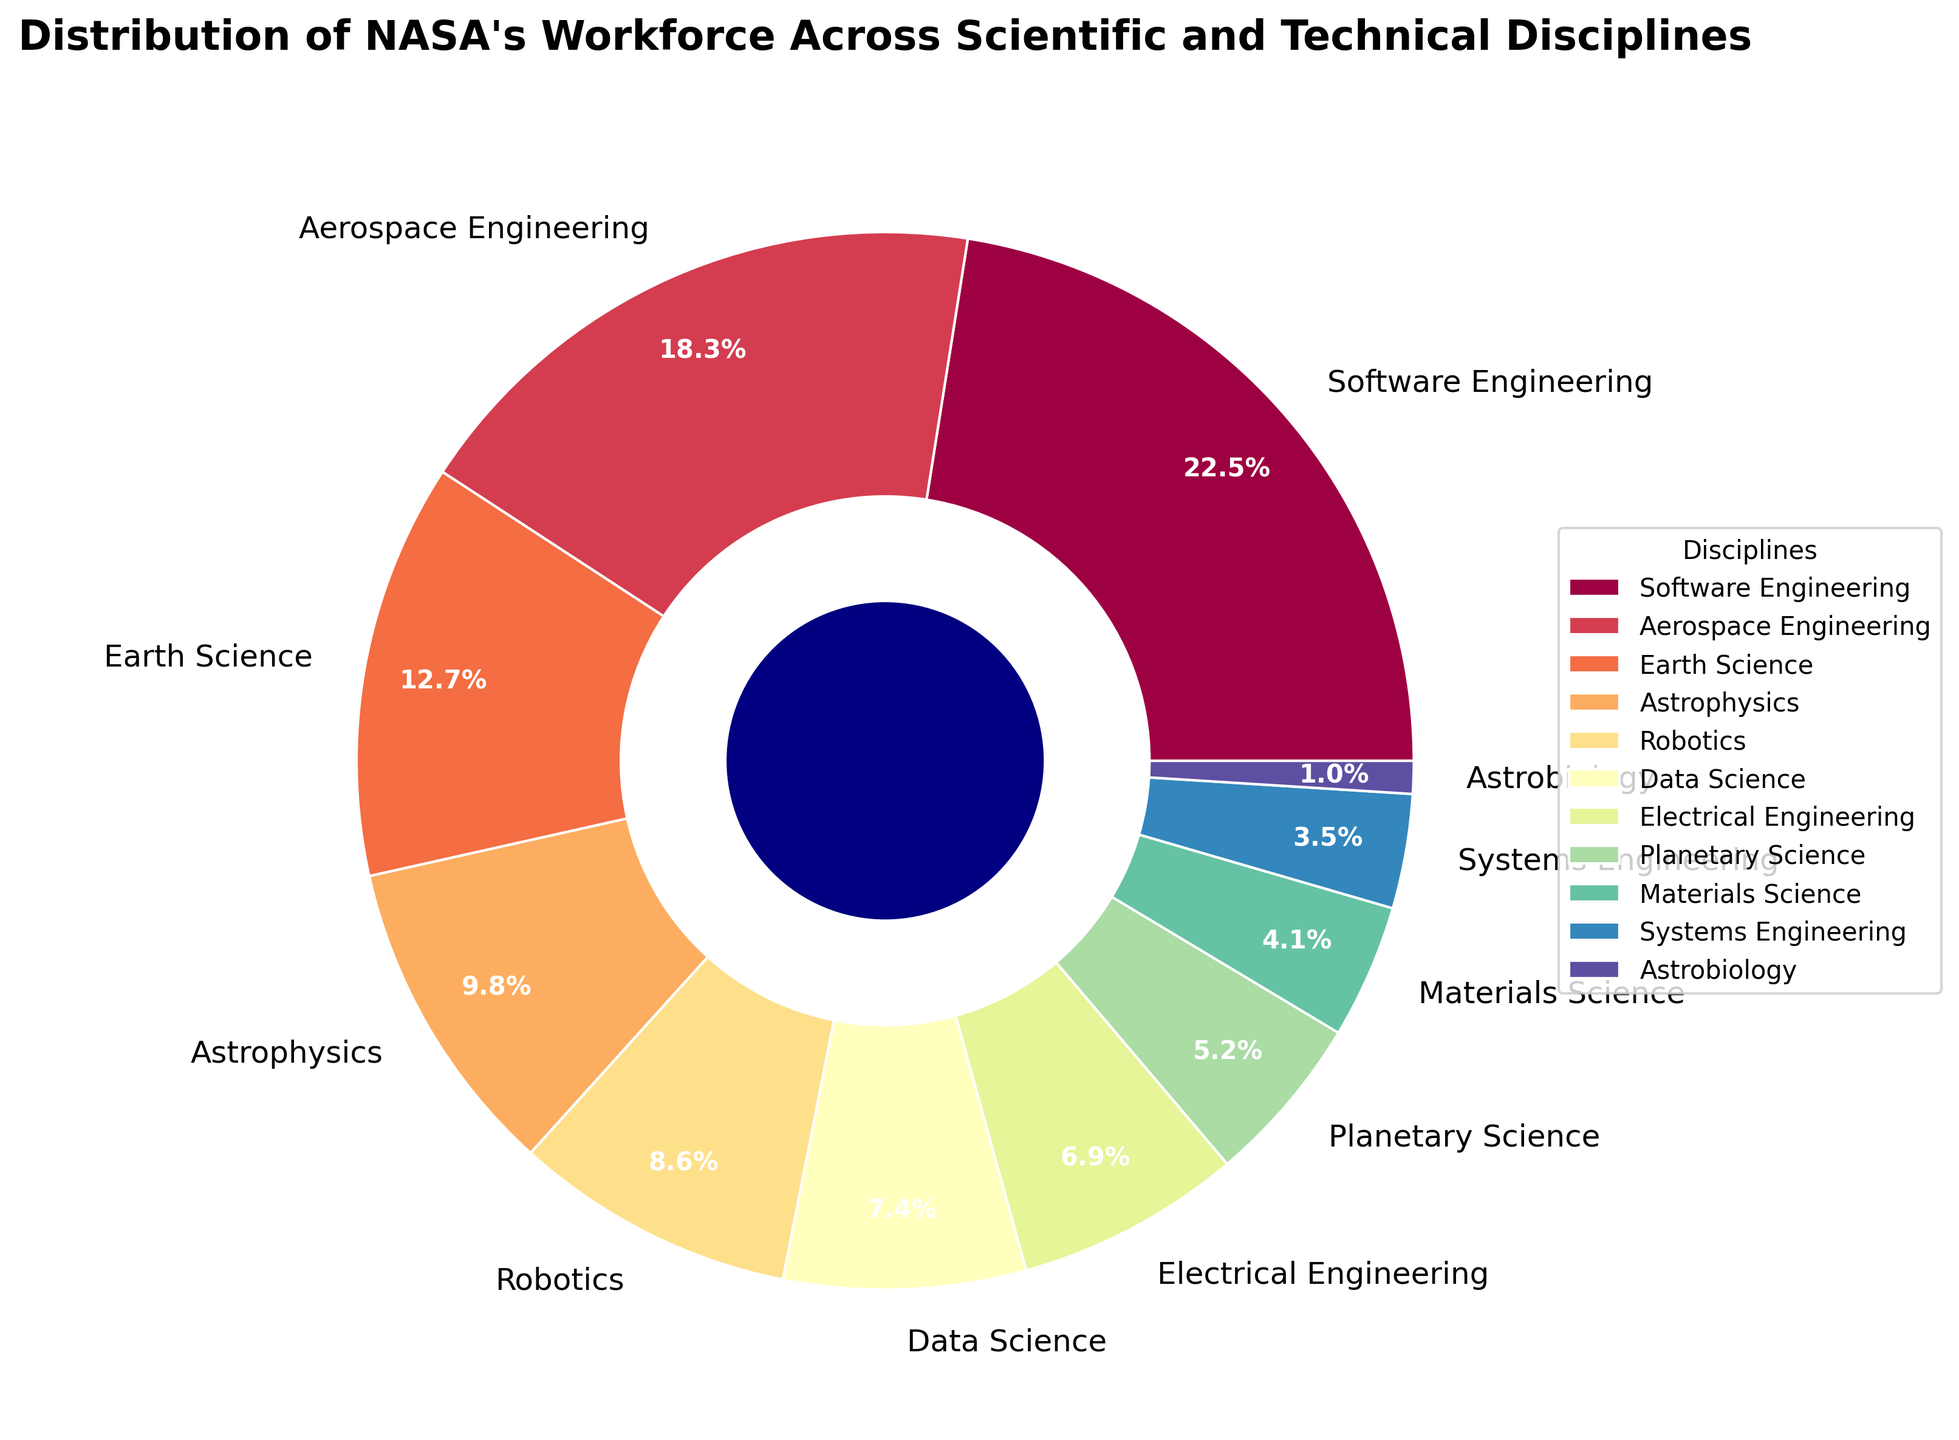Which discipline has the largest percentage of NASA's workforce? By looking at the pie chart, we can see that the largest wedge belongs to Software Engineering with a percentage of 22.5%.
Answer: Software Engineering Which disciplines together make up more than 50% of NASA's workforce? By identifying the disciplines with the highest percentages, we see that Software Engineering (22.5%), Aerospace Engineering (18.3%), and Earth Science (12.7%) add up to 53.5%, which is more than 50%.
Answer: Software Engineering, Aerospace Engineering, Earth Science What is the difference in workforce percentage between Software Engineering and Electrical Engineering? Software Engineering has 22.5% and Electrical Engineering has 6.9%. Subtracting these gives 22.5% - 6.9% = 15.6%.
Answer: 15.6% Which has a higher percentage: Robotics or Data Science? By comparing the two percentages on the pie chart, Robotics has 8.6% while Data Science has 7.4%. Therefore, Robotics has a higher percentage.
Answer: Robotics What is the combined percentage of workforce in Astrophysics, Robotics, and Data Science? Summing up the percentages: Astrophysics (9.8%), Robotics (8.6%), and Data Science (7.4%) gives 9.8% + 8.6% + 7.4% = 25.8%.
Answer: 25.8% Which disciplines have the smallest and the second smallest workforce percentages? The smallest slice belongs to Astrobiology at 1.0%, followed by Systems Engineering with 3.5%.
Answer: Astrobiology and Systems Engineering What percentage of the workforce is involved in various forms of engineering (Software, Aerospace, Electrical, Systems)? Summing the engineering disciplines: Software Engineering (22.5%), Aerospace Engineering (18.3%), Electrical Engineering (6.9%), and Systems Engineering (3.5%) gives 22.5% + 18.3% + 6.9% + 3.5% = 51.2%.
Answer: 51.2% If you add the percentages of the three smallest disciplines, what is the total? Adding the smallest slices: Systems Engineering (3.5%), Materials Science (4.1%), and Astrobiology (1.0%) gives 3.5% + 4.1% + 1.0% = 8.6%.
Answer: 8.6% Which discipline has a workforce percentage closest to 10%? By looking at the percentages, Astrophysics, with 9.8%, is closest to 10%.
Answer: Astrophysics 